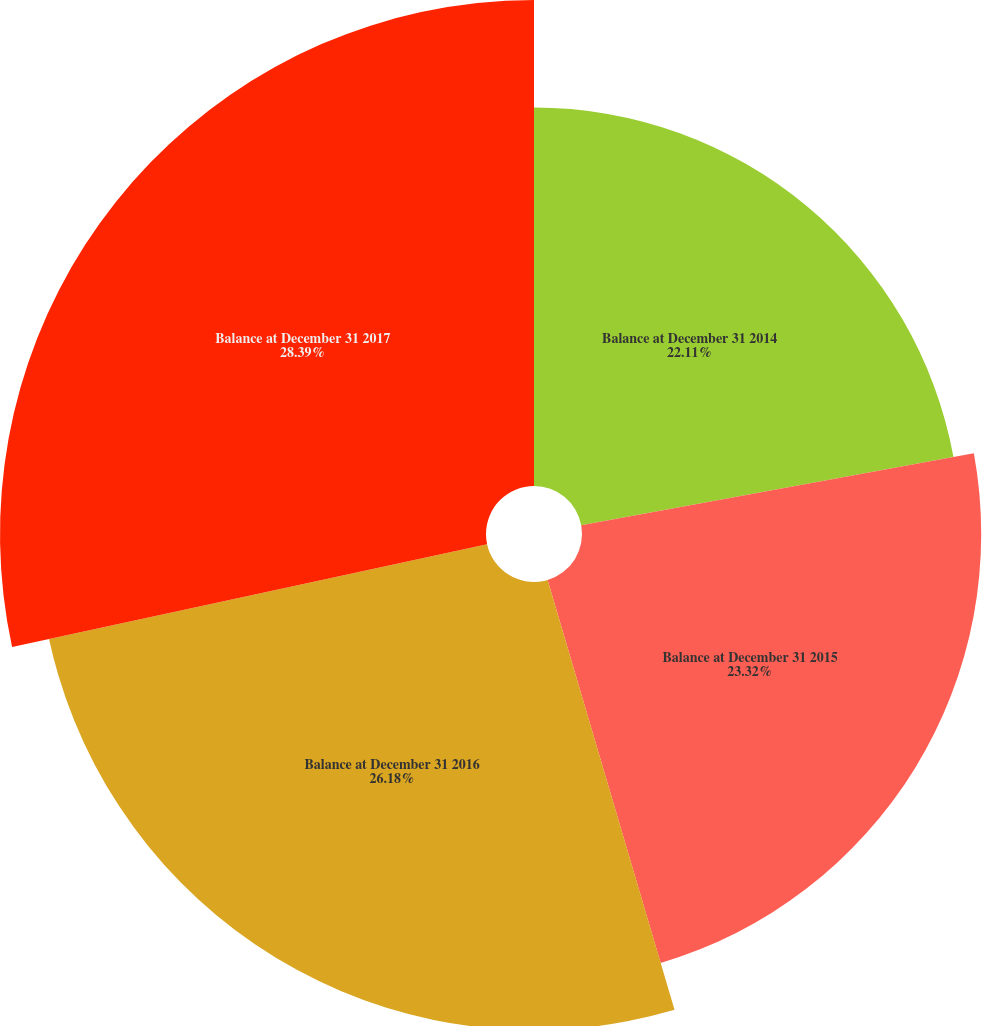Convert chart. <chart><loc_0><loc_0><loc_500><loc_500><pie_chart><fcel>Balance at December 31 2014<fcel>Balance at December 31 2015<fcel>Balance at December 31 2016<fcel>Balance at December 31 2017<nl><fcel>22.11%<fcel>23.32%<fcel>26.18%<fcel>28.39%<nl></chart> 